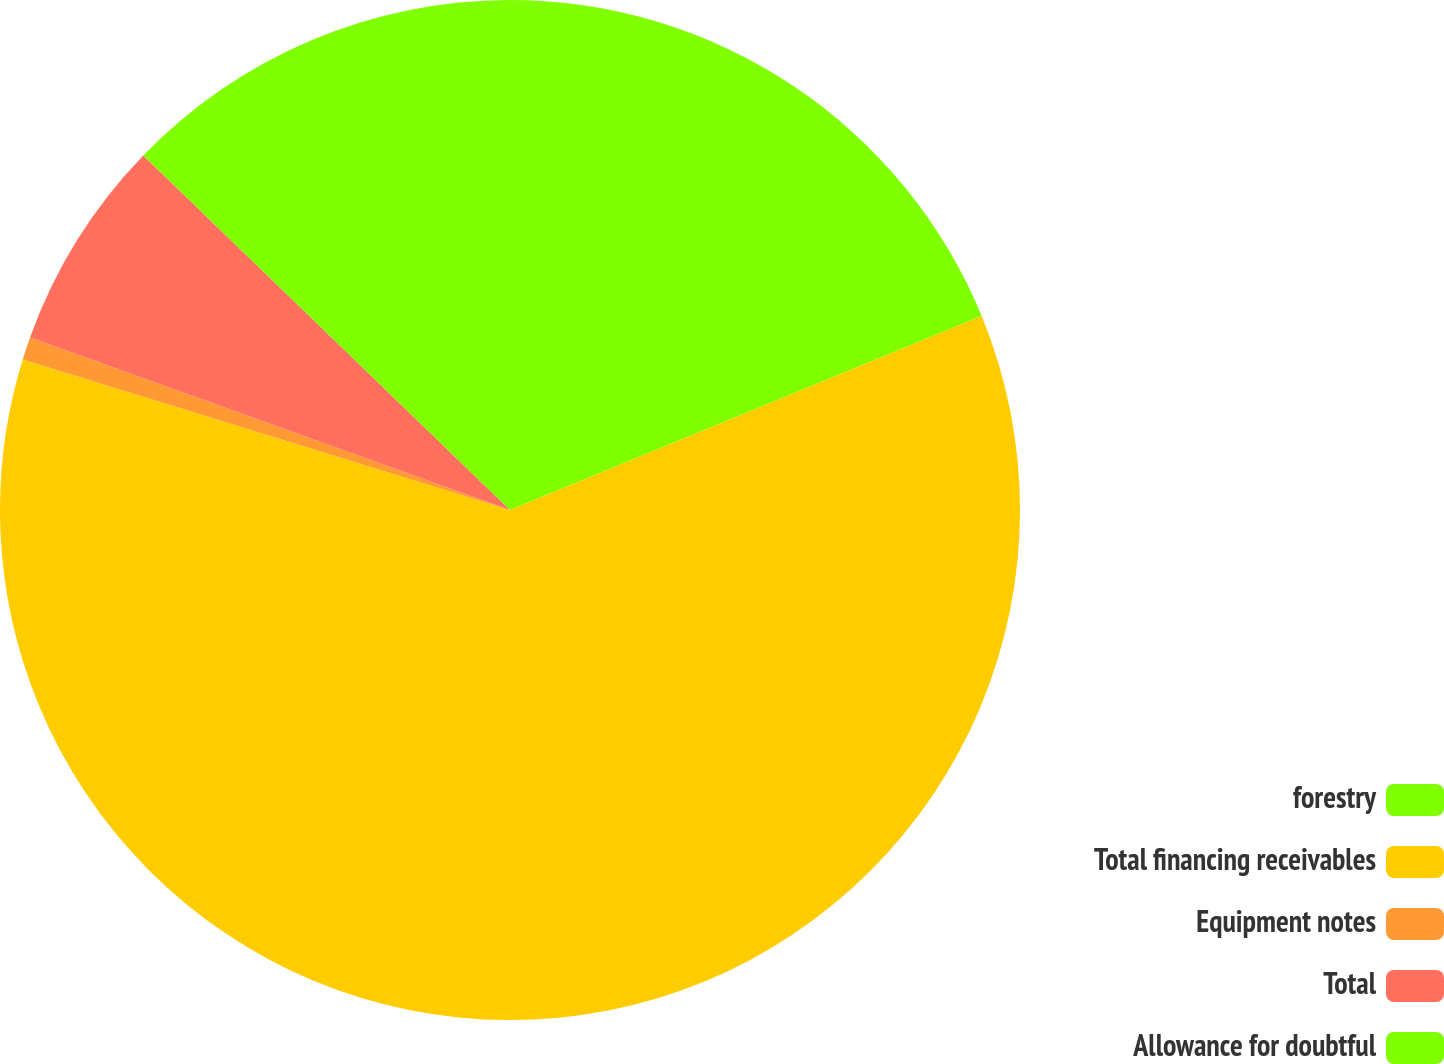<chart> <loc_0><loc_0><loc_500><loc_500><pie_chart><fcel>forestry<fcel>Total financing receivables<fcel>Equipment notes<fcel>Total<fcel>Allowance for doubtful<nl><fcel>18.79%<fcel>60.97%<fcel>0.72%<fcel>6.74%<fcel>12.77%<nl></chart> 